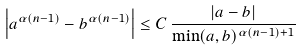<formula> <loc_0><loc_0><loc_500><loc_500>\left | a ^ { \alpha ( n - 1 ) } - b ^ { \alpha ( n - 1 ) } \right | \leq C \, \frac { | a - b | } { \min ( a , b ) ^ { \alpha ( n - 1 ) + 1 } }</formula> 